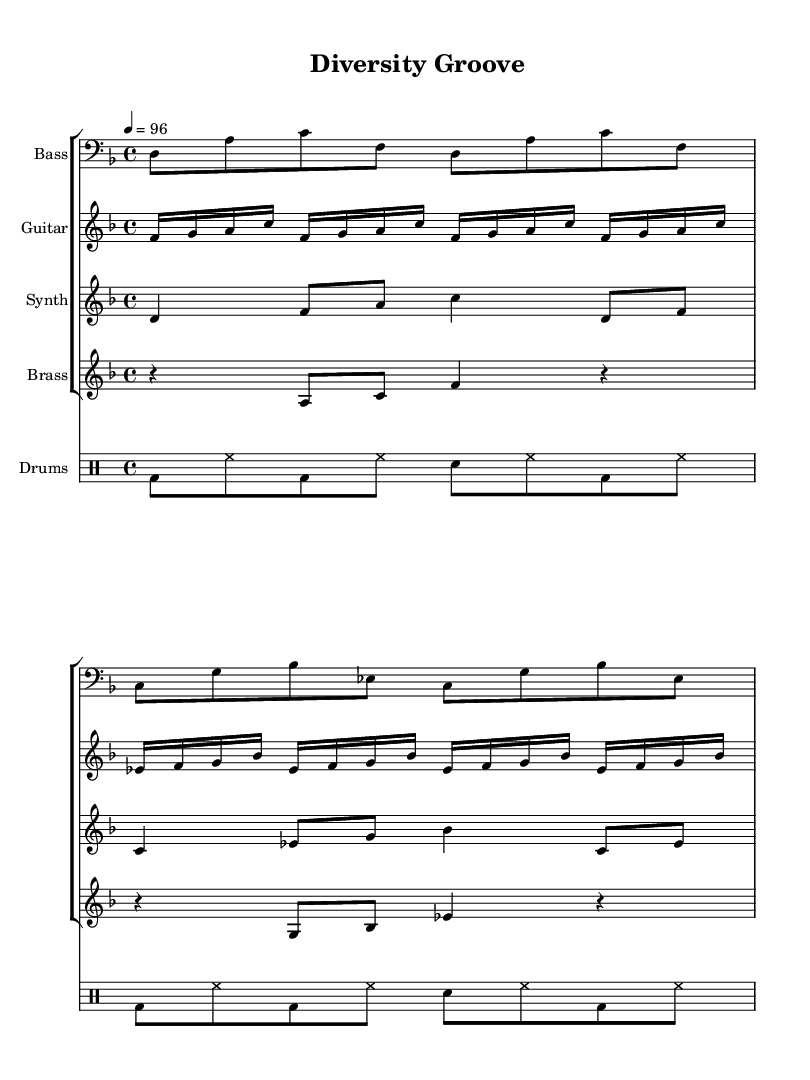What is the key signature of this music? The key signature is D minor, indicated by one flat on the staff (B flat).
Answer: D minor What is the time signature of the piece? The time signature is 4/4, which is represented at the beginning of the score with a "4" on top of another "4".
Answer: 4/4 What is the tempo marking? The tempo marking is "4 = 96", which indicates that there are 96 beats per minute and each beat is a quarter note.
Answer: 96 Which instrument plays the bass line? The bass line is written in the "Bass" staff, which is labeled at the beginning of that staff.
Answer: Bass How many measures are in the bass line? Counting the measures in the bass line, there are four measures in total. Each group of notes separated by vertical lines represents a measure.
Answer: 4 What rhythmic value are the drums playing for the bass drum in the first measure? The bass drum in the first measure is playing eighth notes, as denoted by the notation in the drum part.
Answer: Eighth notes What makes this piece qualify as "Funk"? This piece qualifies as "Funk" due to the syncopated rhythms, strong backbeat from the drums, and the use of a groove-oriented bass line that emphasizes the "off-beats".
Answer: Syncopated rhythms 